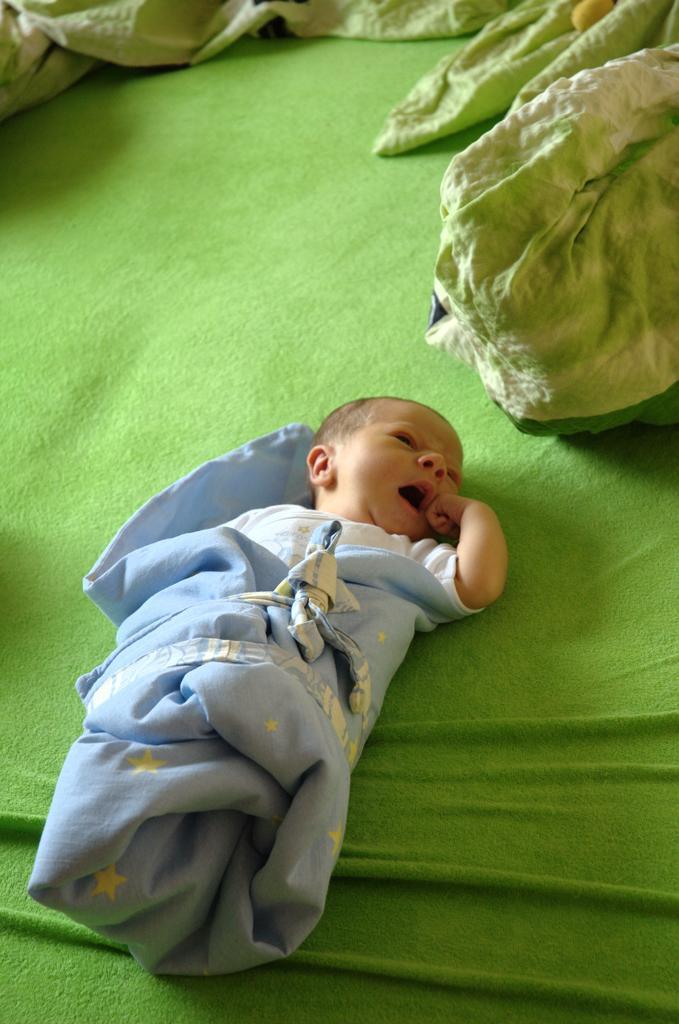Can you describe this image briefly? In this image I can see a green colour cloth and on it I can see a child. I can also see a blue colour cloth around the child. On the top side of the image I can see one more green colour cloth. 